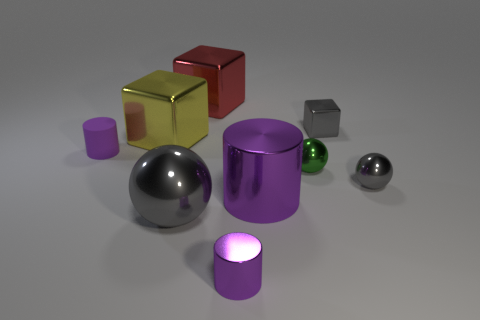Subtract all purple cylinders. How many were subtracted if there are1purple cylinders left? 2 Subtract all blue blocks. Subtract all red cylinders. How many blocks are left? 3 Subtract all spheres. How many objects are left? 6 Subtract 1 red blocks. How many objects are left? 8 Subtract all large blue rubber balls. Subtract all purple cylinders. How many objects are left? 6 Add 8 big yellow blocks. How many big yellow blocks are left? 9 Add 8 large yellow objects. How many large yellow objects exist? 9 